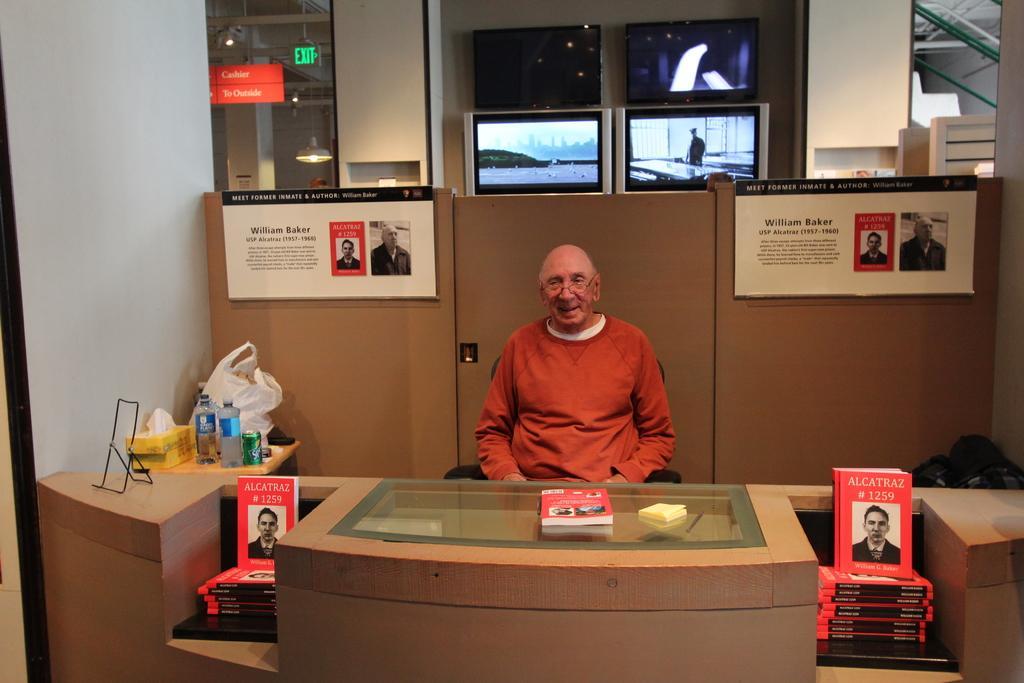In one or two sentences, can you explain what this image depicts? In this picture we can see a man who is sitting on the chair. This is table. On the table there are books, bottles, boxes, and a tin. On the background there are screens and this is door. Here we can see some posters. 